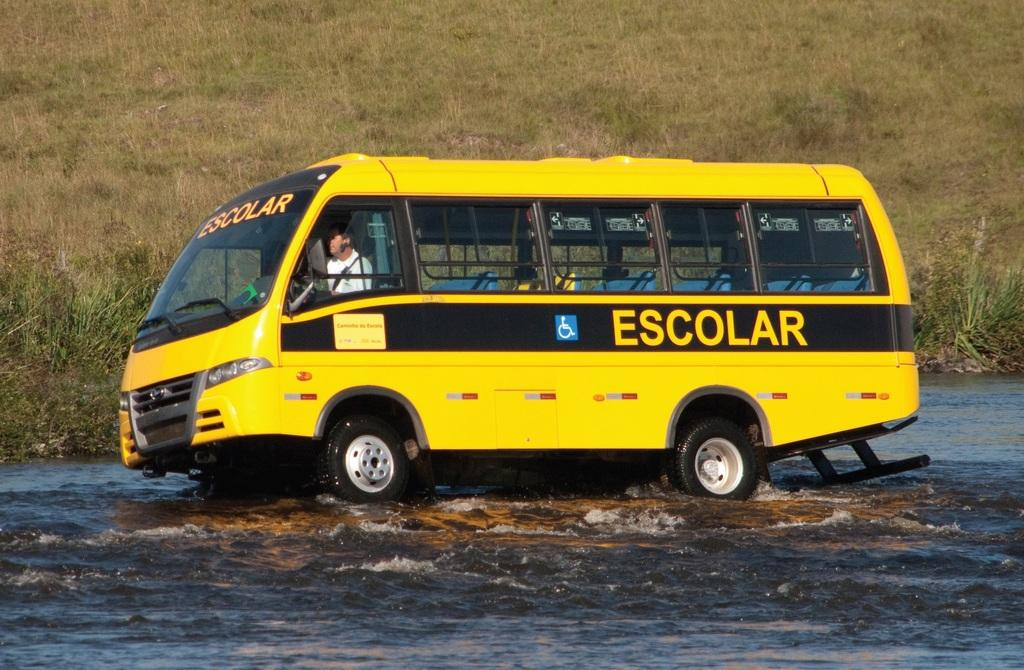<image>
Describe the image concisely. a yellow and black bus with the word Escolar on the body 